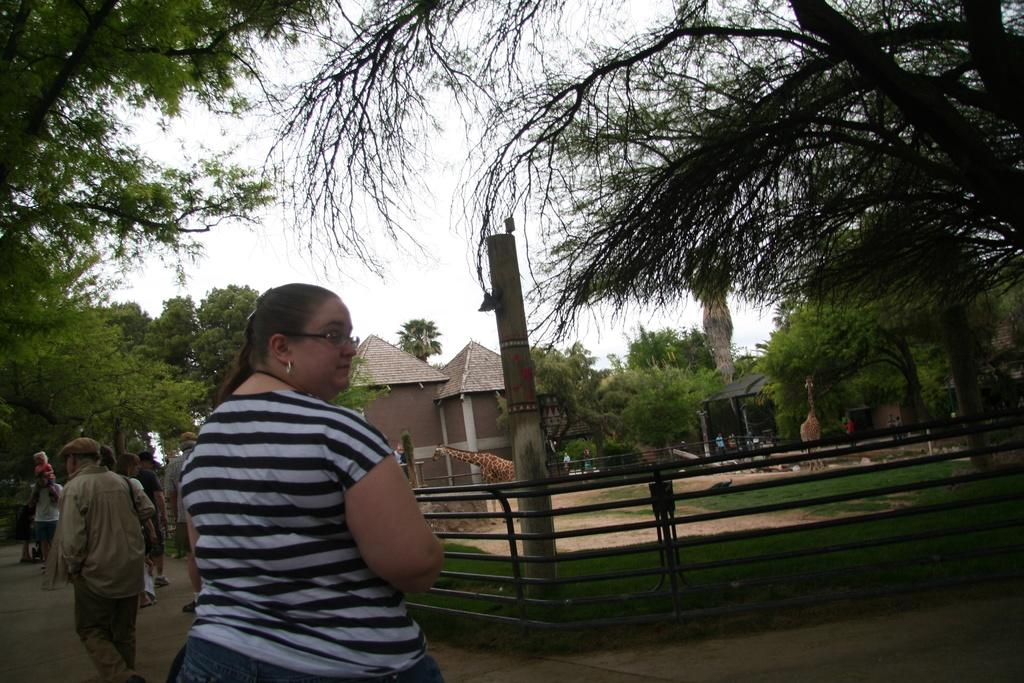What are the people in the image doing? The people in the image are walking on a road. What can be seen in the background of the image? In the background, there is a railing, giraffes, trees, houses, and the sky. How many different types of structures are visible in the background? There are two types of structures visible in the background: railing and houses. What is the governor doing in the image? There is no governor present in the image. How many trucks can be seen in the image? There are no trucks visible in the image. 